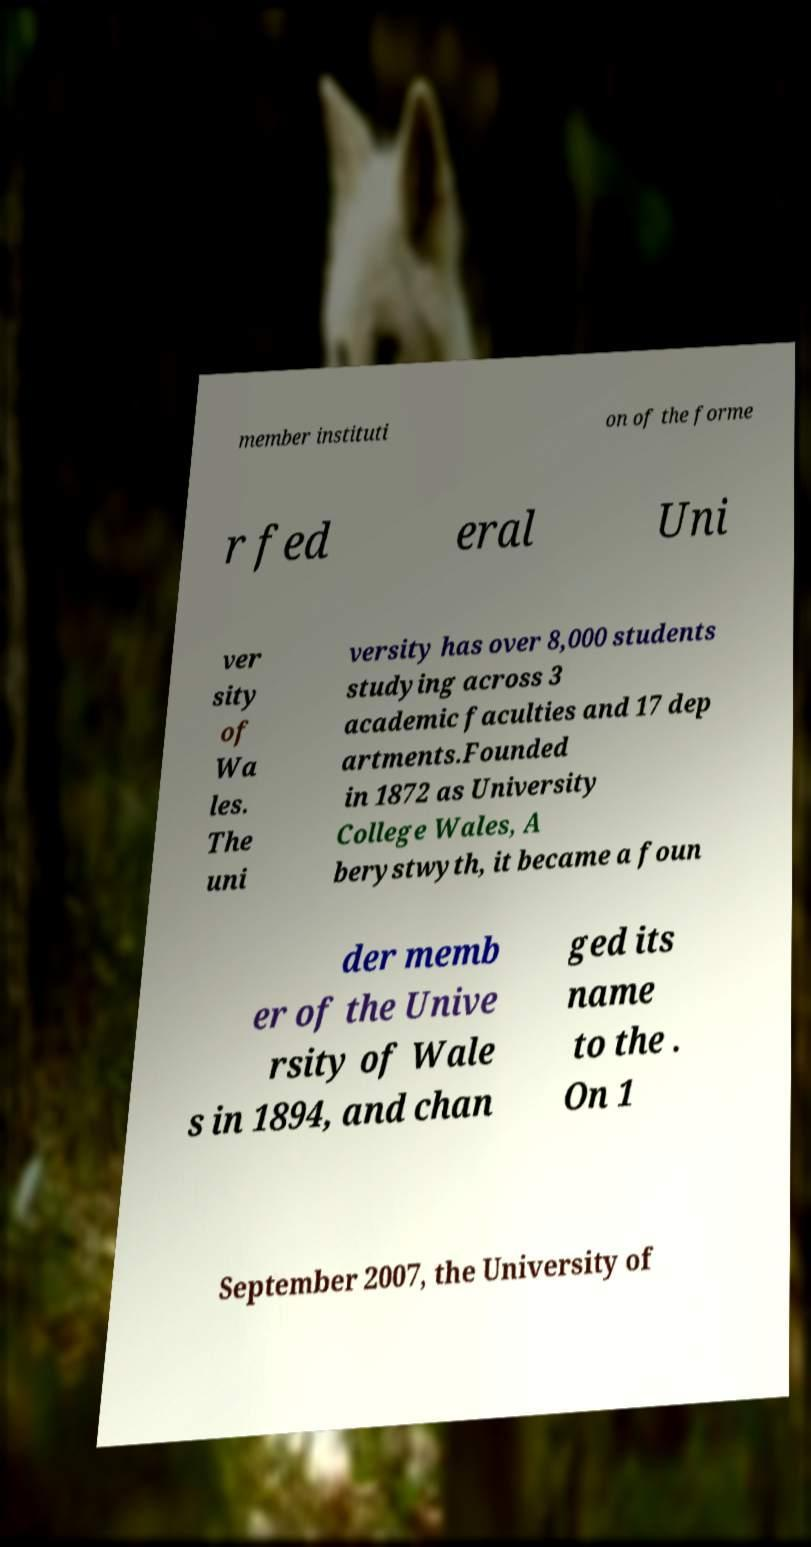Please read and relay the text visible in this image. What does it say? member instituti on of the forme r fed eral Uni ver sity of Wa les. The uni versity has over 8,000 students studying across 3 academic faculties and 17 dep artments.Founded in 1872 as University College Wales, A berystwyth, it became a foun der memb er of the Unive rsity of Wale s in 1894, and chan ged its name to the . On 1 September 2007, the University of 